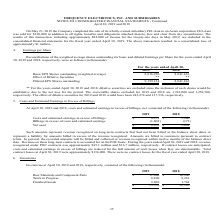From Frequency Electronics's financial document, What is the amount of raw materials and component parts in 2019 and 2018 respectively? The document shows two values: $11,600 and $ 16,206 (in thousands). From the document: "s): 2019 2018 Raw Materials and Component Parts $ 11,600 $ 16,206 19 2018 Raw Materials and Component Parts $ 11,600 $ 16,206..." Also, What is the amount of work in progress inventory in 2019 and 2018 respectively? The document shows two values: 8,896 and 8,216 (in thousands). From the document: "Work in Progress 8,896 8,216 Finished Goods 2,860 1,764 $ 23,356 $ 26,186 Work in Progress 8,896 8,216 Finished Goods 2,860 1,764 $ 23,356 $ 26,186..." Also, What is the amount of finished goods in 2019 and 2018 respectively? The document shows two values: 2,860 and 1,764 (in thousands). From the document: "Work in Progress 8,896 8,216 Finished Goods 2,860 1,764 $ 23,356 $ 26,186 Work in Progress 8,896 8,216 Finished Goods 2,860 1,764 $ 23,356 $ 26,186..." Also, can you calculate: What is the average amount of raw materials and component parts in 2018 and 2019? To answer this question, I need to perform calculations using the financial data. The calculation is: (11,600+16,206)/2, which equals 13903 (in thousands). This is based on the information: "2018 Raw Materials and Component Parts $ 11,600 $ 16,206 s): 2019 2018 Raw Materials and Component Parts $ 11,600 $ 16,206..." The key data points involved are: 11,600, 16,206. Also, can you calculate: In 2019, what is the percentage constitution of finished goods among the total inventory amount? Based on the calculation: 2,860/23,356, the result is 12.25 (percentage). This is based on the information: "Work in Progress 8,896 8,216 Finished Goods 2,860 1,764 $ 23,356 $ 26,186 Progress 8,896 8,216 Finished Goods 2,860 1,764 $ 23,356 $ 26,186..." The key data points involved are: 2,860, 23,356. Also, can you calculate: What is the percentage change of amount of inventory from 2018 and 2019 ? To answer this question, I need to perform calculations using the financial data. The calculation is: (23,356-26,186)/26,186, which equals -10.81 (percentage). This is based on the information: "8,896 8,216 Finished Goods 2,860 1,764 $ 23,356 $ 26,186 Progress 8,896 8,216 Finished Goods 2,860 1,764 $ 23,356 $ 26,186..." The key data points involved are: 23,356, 26,186. 